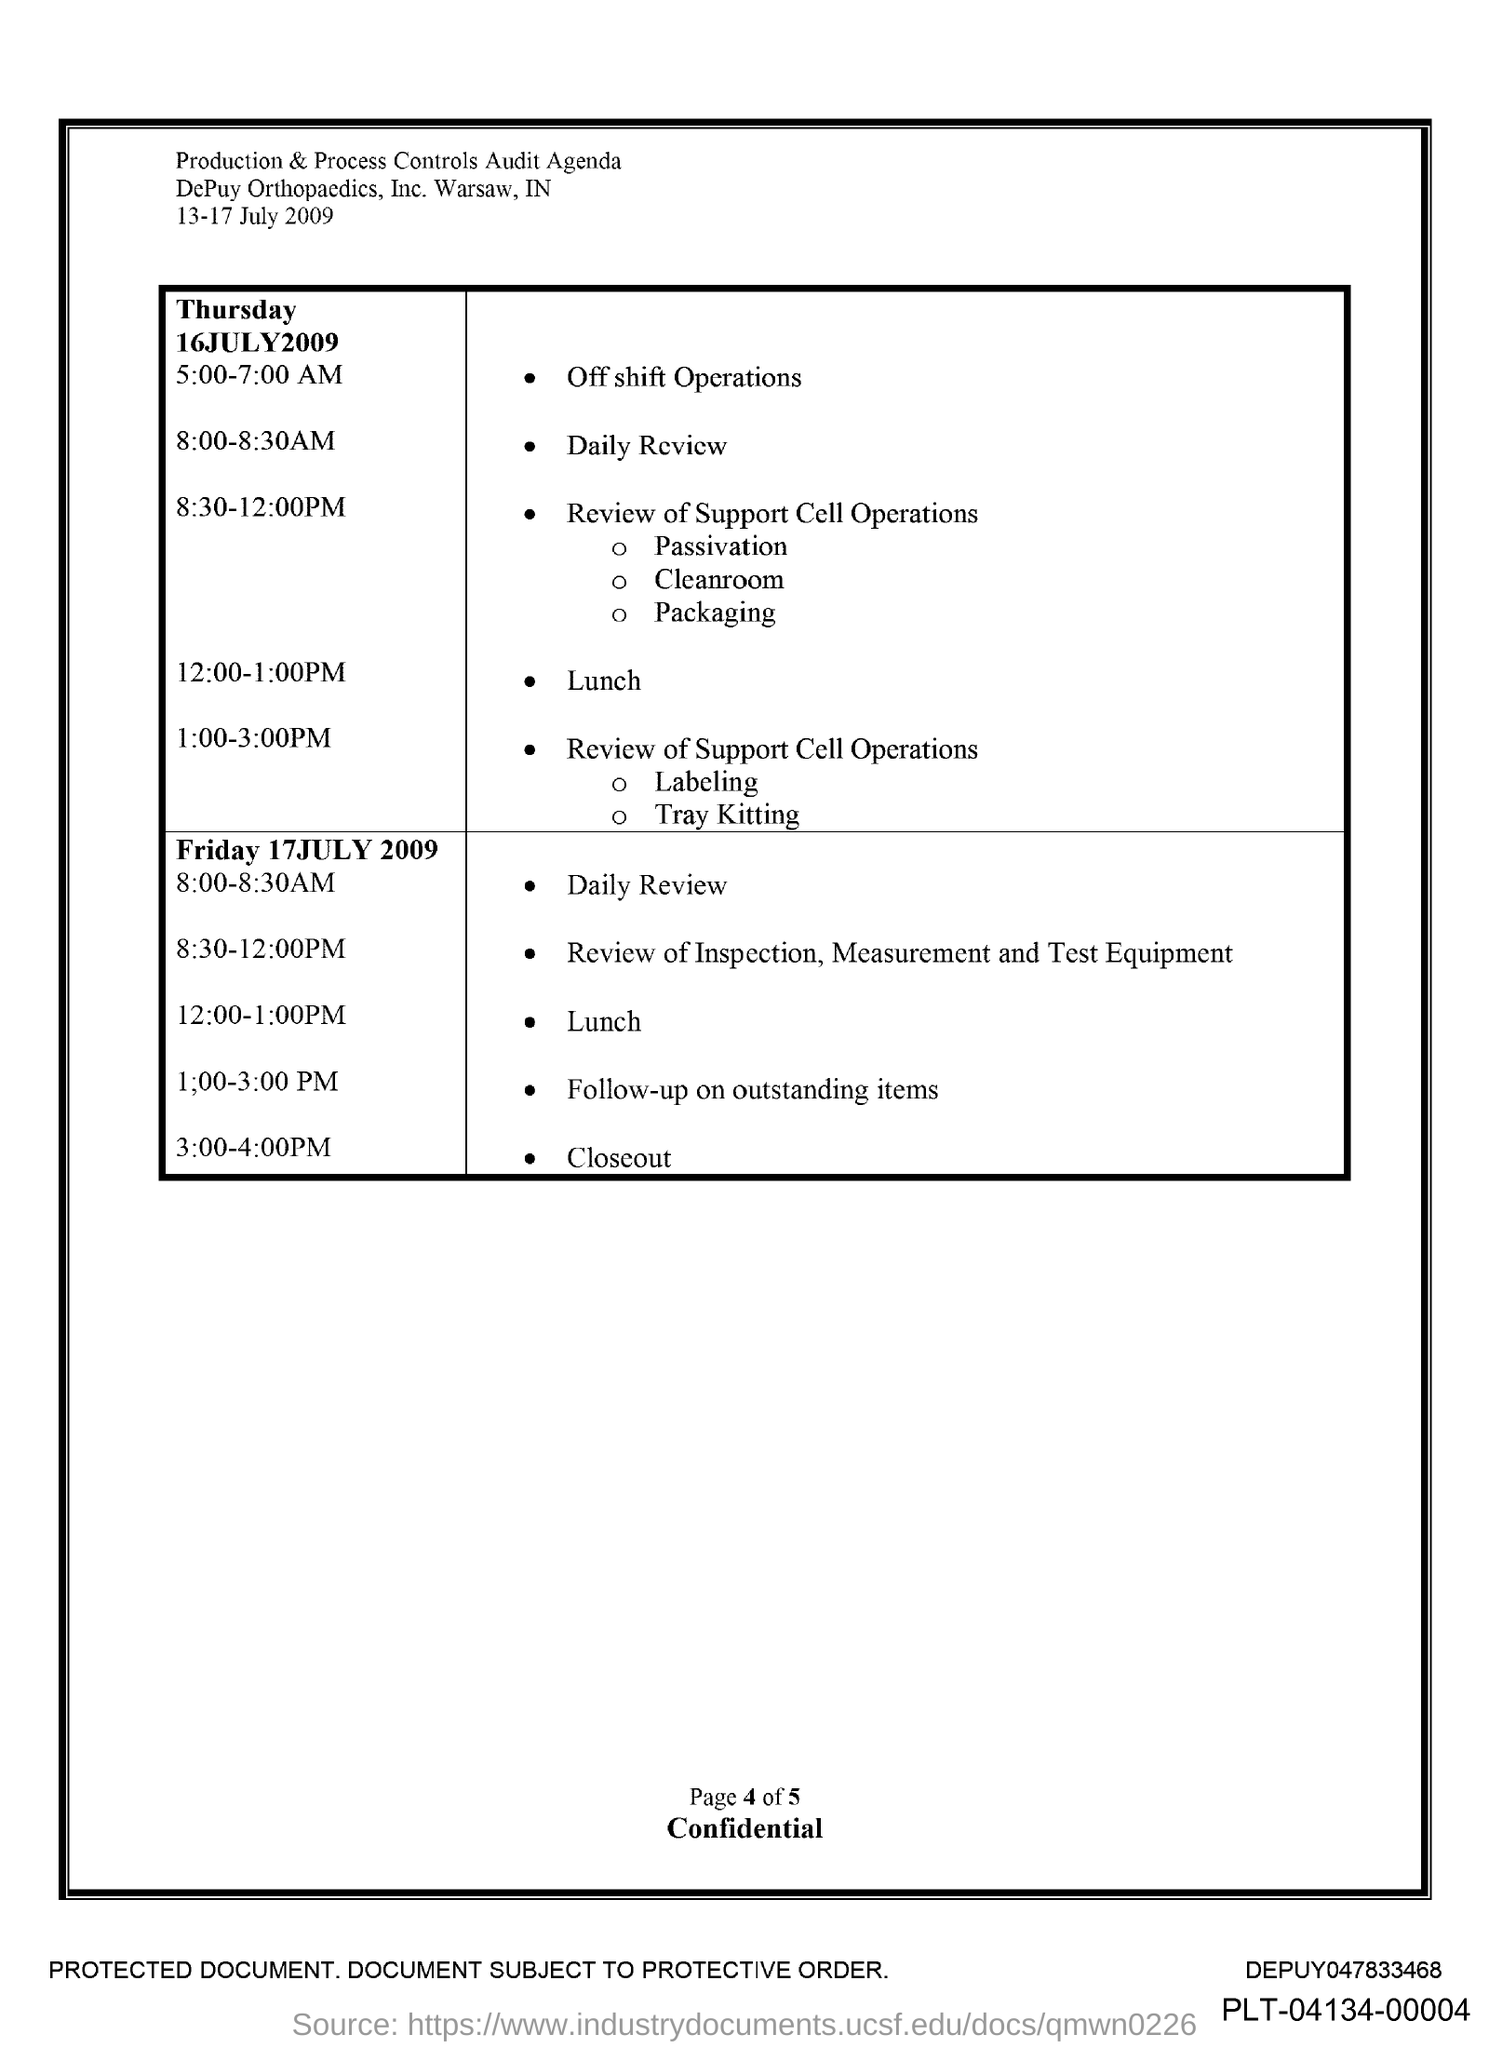What is the Time for Daily Review on Thursday 16 July 2009?
Offer a very short reply. 8:00-8:30AM. What is the Time for Lunch on Thursday 16 July 2009?
Your answer should be compact. 12:00-1:00PM. 